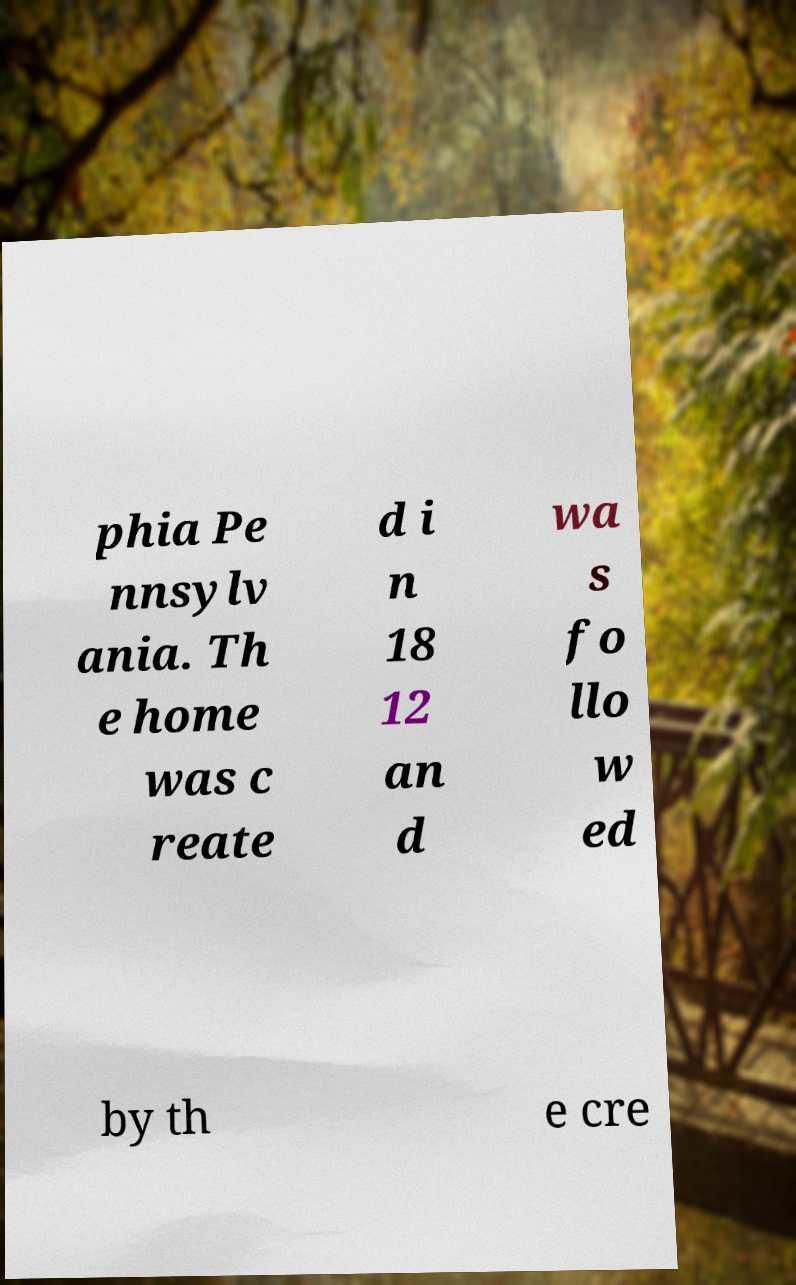There's text embedded in this image that I need extracted. Can you transcribe it verbatim? phia Pe nnsylv ania. Th e home was c reate d i n 18 12 an d wa s fo llo w ed by th e cre 